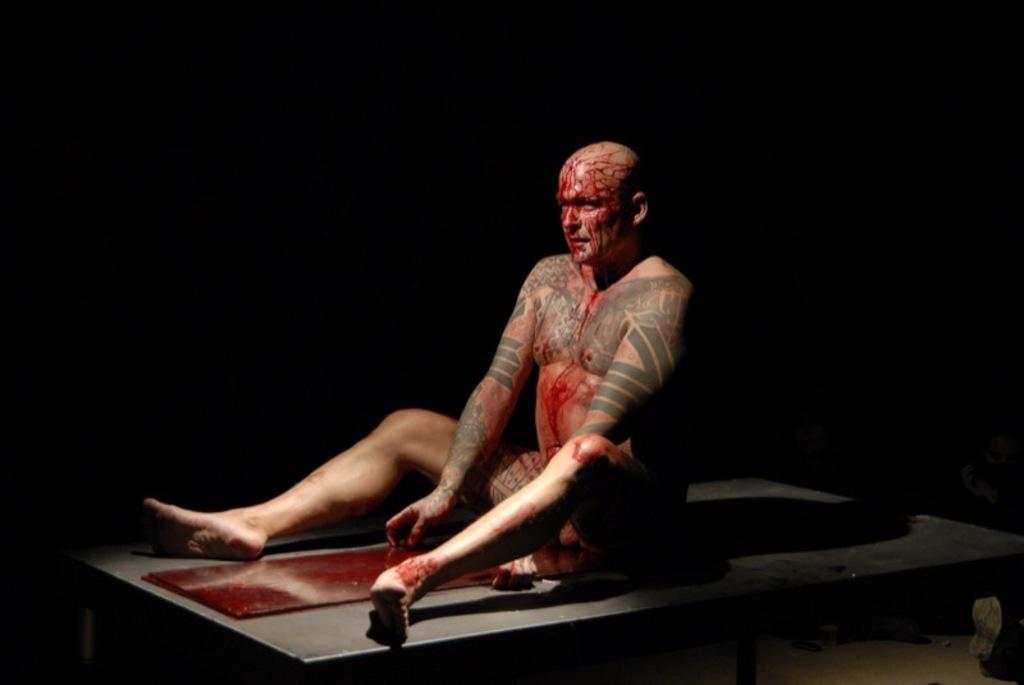Who is present in the image? There is a man in the image. What is the man doing in the image? The man is sitting on a table. What can be observed about the background of the image? The background of the image is dark. Where is the playground located in the image? There is no playground present in the image. What shape is the square in the image? There is no square present in the image. Can you tell me how many teeth the man has in the image? The image does not show the man's teeth, so it is not possible to determine how many teeth he has. 